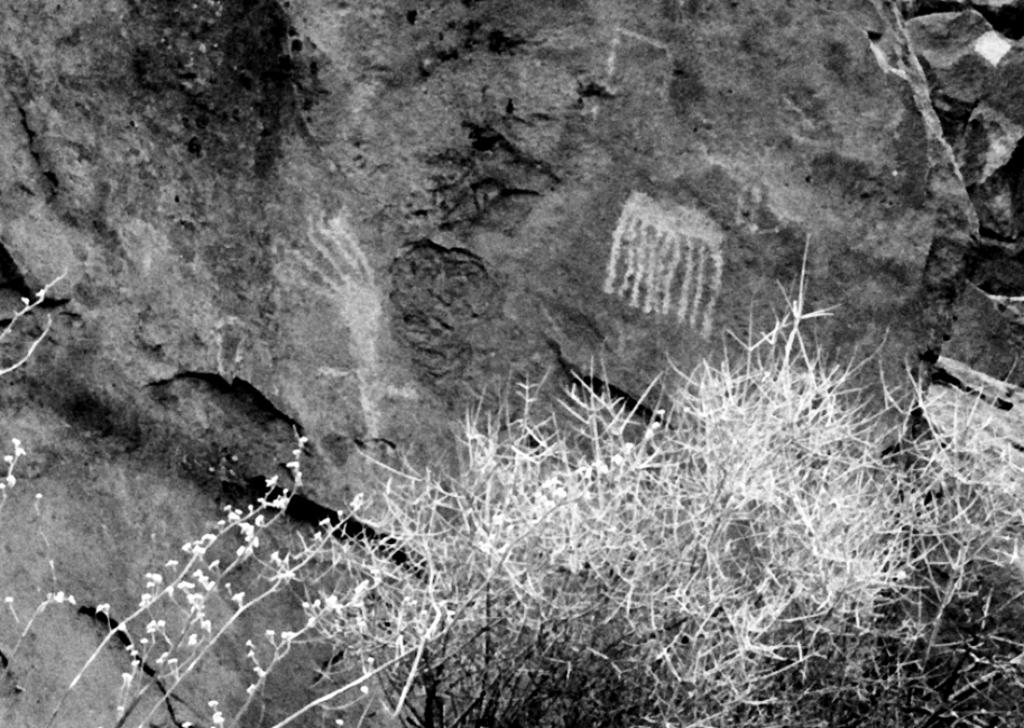What type of living organisms can be seen in the image? Plants can be seen in the image. What other objects are present in the image besides plants? There are rocks in the image. What type of acoustics can be heard from the plants in the image? There is no sound or acoustics associated with the plants in the image. What type of flowers can be seen growing among the plants in the image? There is no mention of flowers in the image; only plants and rocks are present. 